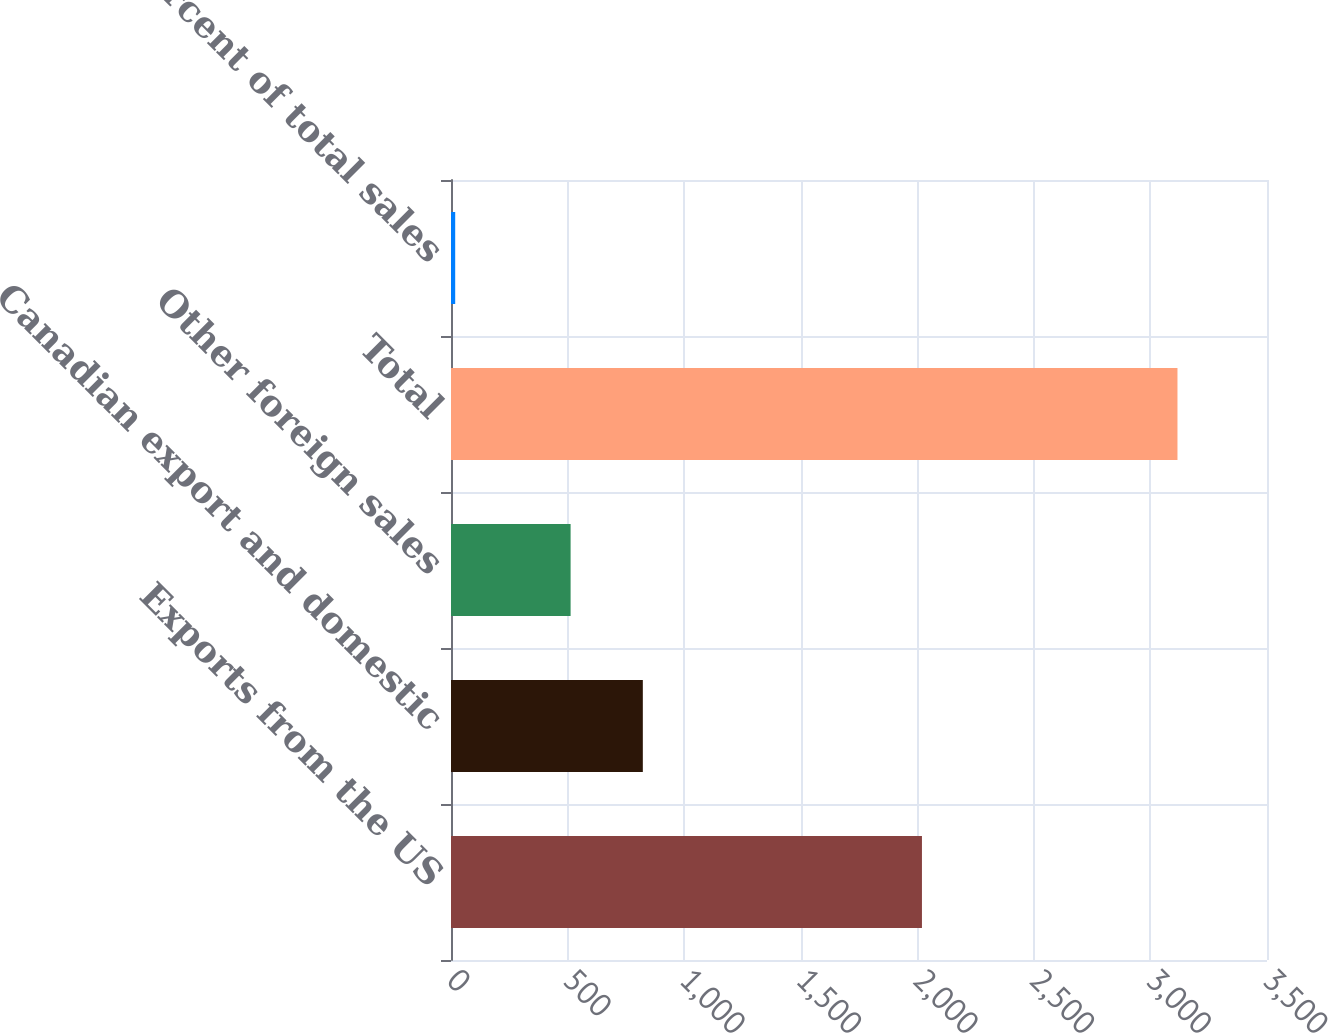<chart> <loc_0><loc_0><loc_500><loc_500><bar_chart><fcel>Exports from the US<fcel>Canadian export and domestic<fcel>Other foreign sales<fcel>Total<fcel>Percent of total sales<nl><fcel>2020<fcel>822.8<fcel>513<fcel>3116<fcel>18<nl></chart> 